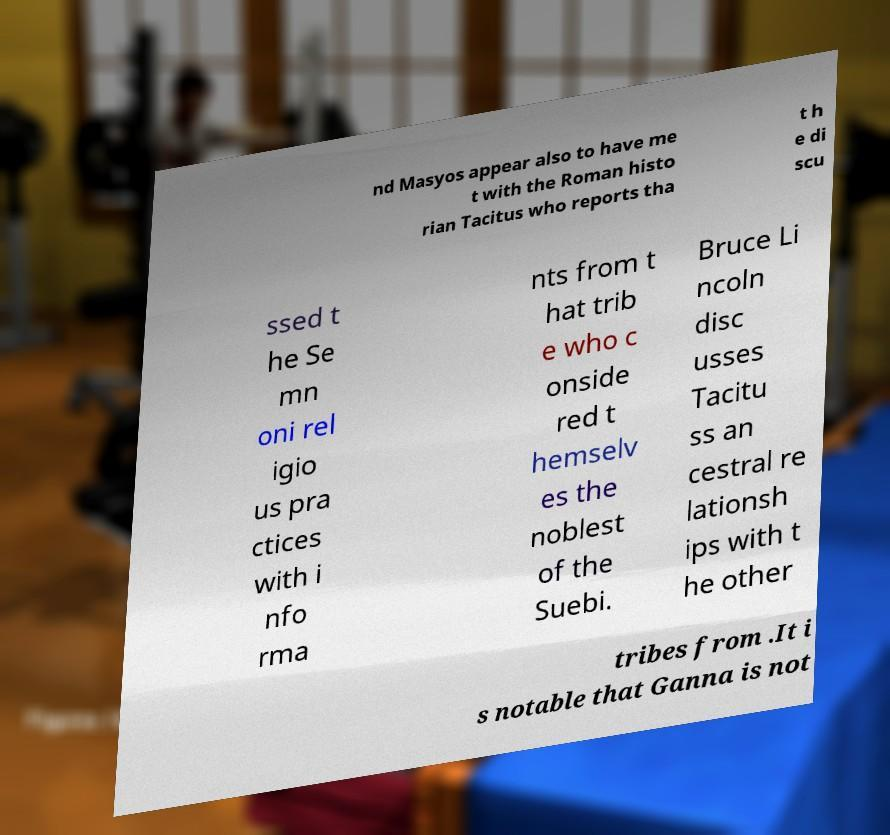Could you assist in decoding the text presented in this image and type it out clearly? nd Masyos appear also to have me t with the Roman histo rian Tacitus who reports tha t h e di scu ssed t he Se mn oni rel igio us pra ctices with i nfo rma nts from t hat trib e who c onside red t hemselv es the noblest of the Suebi. Bruce Li ncoln disc usses Tacitu ss an cestral re lationsh ips with t he other tribes from .It i s notable that Ganna is not 